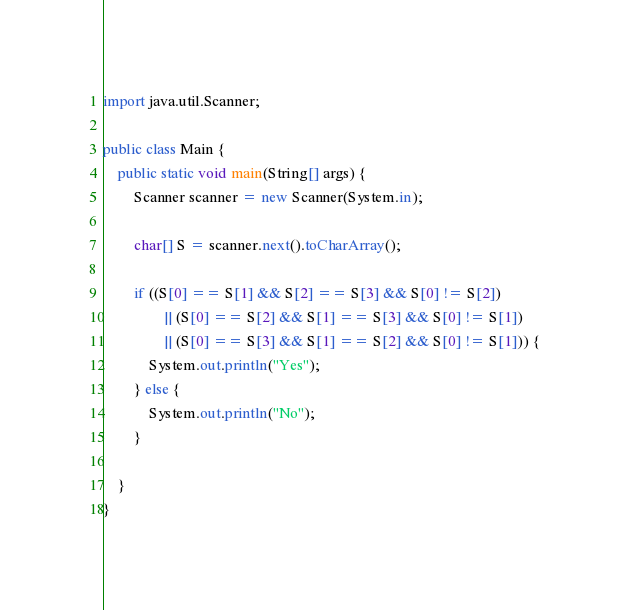<code> <loc_0><loc_0><loc_500><loc_500><_Java_>
import java.util.Scanner;

public class Main {
    public static void main(String[] args) {
        Scanner scanner = new Scanner(System.in);

        char[] S = scanner.next().toCharArray();

        if ((S[0] == S[1] && S[2] == S[3] && S[0] != S[2])
                || (S[0] == S[2] && S[1] == S[3] && S[0] != S[1])
                || (S[0] == S[3] && S[1] == S[2] && S[0] != S[1])) {
            System.out.println("Yes");
        } else {
            System.out.println("No");
        }

    }
}
</code> 